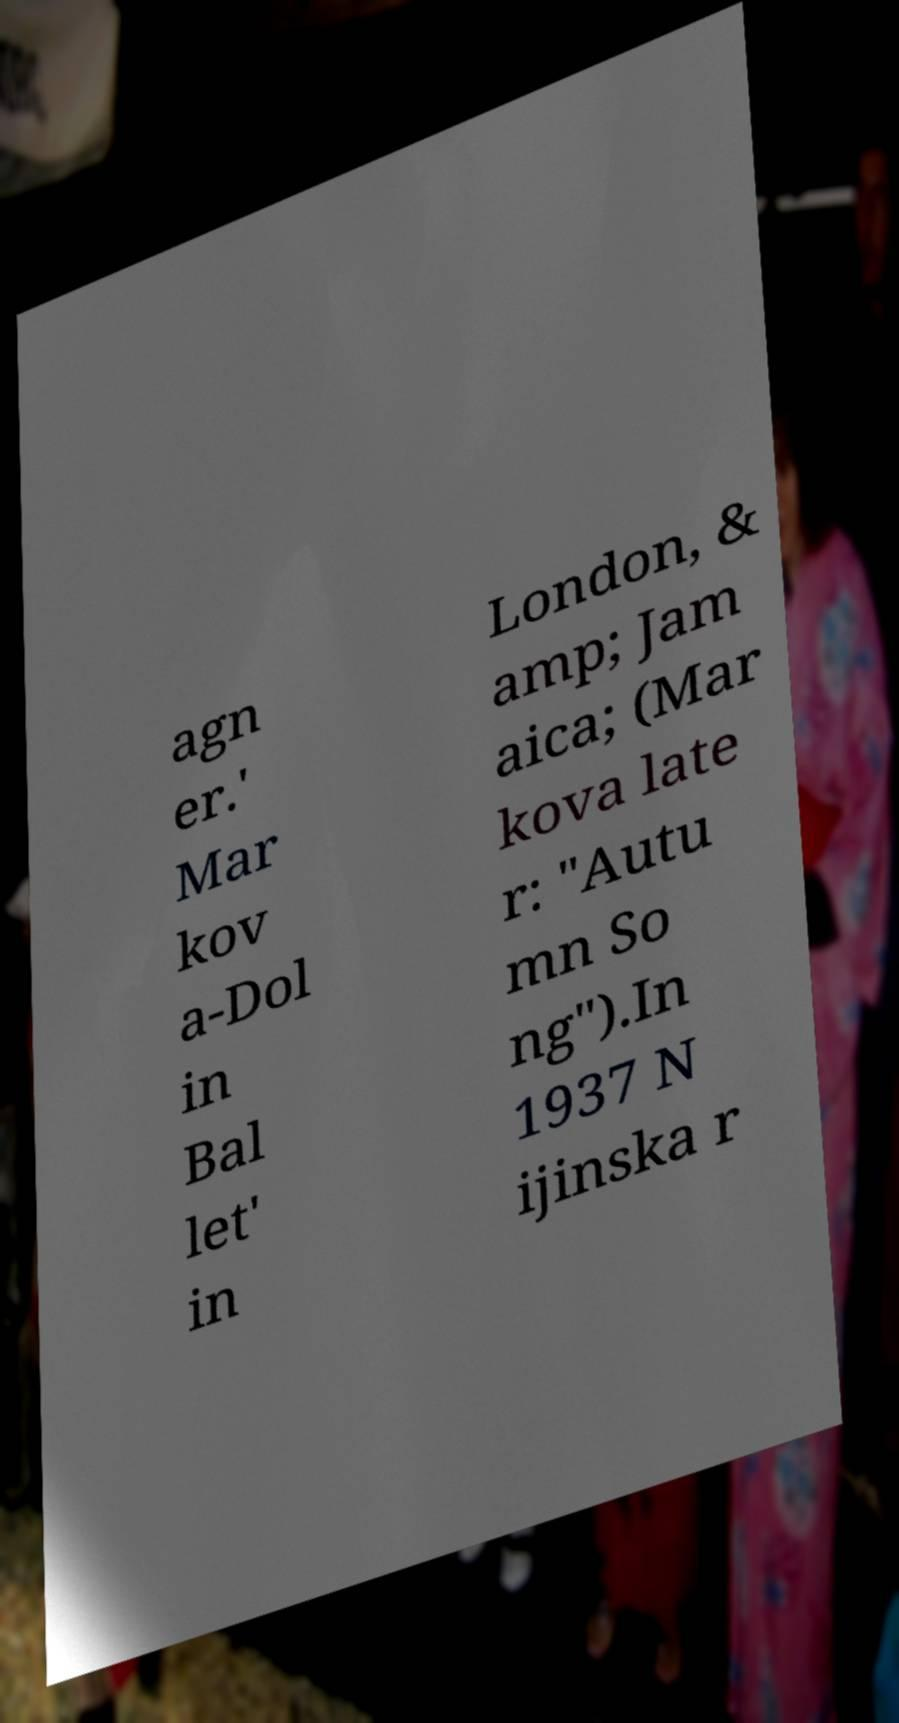Could you extract and type out the text from this image? agn er.' Mar kov a-Dol in Bal let' in London, & amp; Jam aica; (Mar kova late r: "Autu mn So ng").In 1937 N ijinska r 